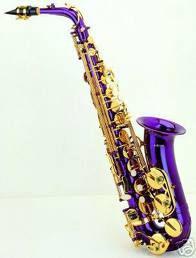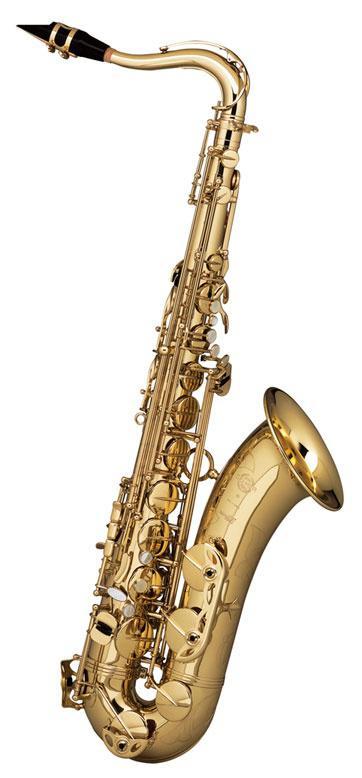The first image is the image on the left, the second image is the image on the right. Examine the images to the left and right. Is the description "There are the same number of saxophones in each of the images." accurate? Answer yes or no. Yes. The first image is the image on the left, the second image is the image on the right. Assess this claim about the two images: "Each image shows just one saxophone that is out of its case.". Correct or not? Answer yes or no. Yes. 